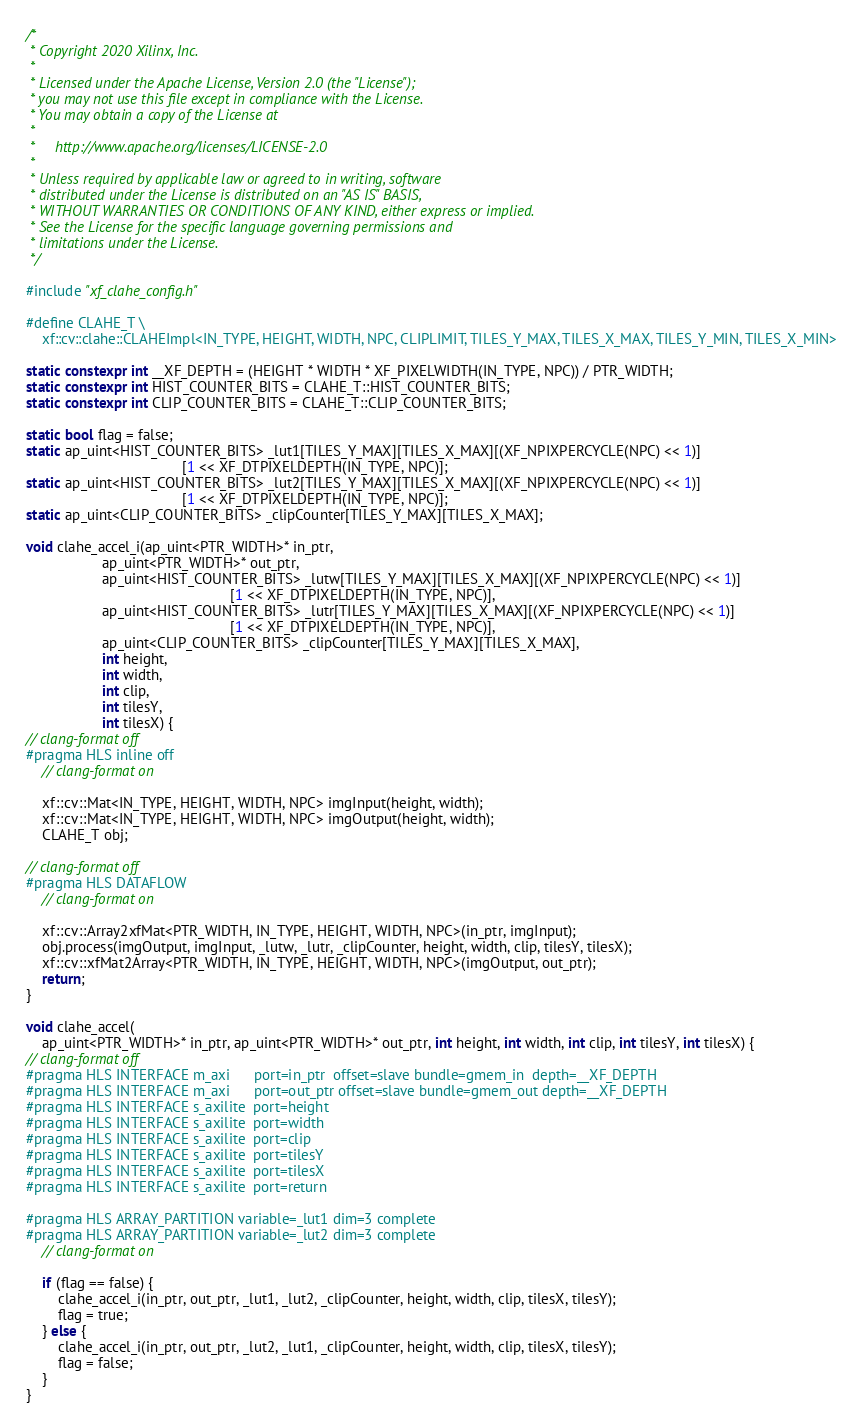<code> <loc_0><loc_0><loc_500><loc_500><_C++_>/*
 * Copyright 2020 Xilinx, Inc.
 *
 * Licensed under the Apache License, Version 2.0 (the "License");
 * you may not use this file except in compliance with the License.
 * You may obtain a copy of the License at
 *
 *     http://www.apache.org/licenses/LICENSE-2.0
 *
 * Unless required by applicable law or agreed to in writing, software
 * distributed under the License is distributed on an "AS IS" BASIS,
 * WITHOUT WARRANTIES OR CONDITIONS OF ANY KIND, either express or implied.
 * See the License for the specific language governing permissions and
 * limitations under the License.
 */

#include "xf_clahe_config.h"

#define CLAHE_T \
    xf::cv::clahe::CLAHEImpl<IN_TYPE, HEIGHT, WIDTH, NPC, CLIPLIMIT, TILES_Y_MAX, TILES_X_MAX, TILES_Y_MIN, TILES_X_MIN>

static constexpr int __XF_DEPTH = (HEIGHT * WIDTH * XF_PIXELWIDTH(IN_TYPE, NPC)) / PTR_WIDTH;
static constexpr int HIST_COUNTER_BITS = CLAHE_T::HIST_COUNTER_BITS;
static constexpr int CLIP_COUNTER_BITS = CLAHE_T::CLIP_COUNTER_BITS;

static bool flag = false;
static ap_uint<HIST_COUNTER_BITS> _lut1[TILES_Y_MAX][TILES_X_MAX][(XF_NPIXPERCYCLE(NPC) << 1)]
                                       [1 << XF_DTPIXELDEPTH(IN_TYPE, NPC)];
static ap_uint<HIST_COUNTER_BITS> _lut2[TILES_Y_MAX][TILES_X_MAX][(XF_NPIXPERCYCLE(NPC) << 1)]
                                       [1 << XF_DTPIXELDEPTH(IN_TYPE, NPC)];
static ap_uint<CLIP_COUNTER_BITS> _clipCounter[TILES_Y_MAX][TILES_X_MAX];

void clahe_accel_i(ap_uint<PTR_WIDTH>* in_ptr,
                   ap_uint<PTR_WIDTH>* out_ptr,
                   ap_uint<HIST_COUNTER_BITS> _lutw[TILES_Y_MAX][TILES_X_MAX][(XF_NPIXPERCYCLE(NPC) << 1)]
                                                   [1 << XF_DTPIXELDEPTH(IN_TYPE, NPC)],
                   ap_uint<HIST_COUNTER_BITS> _lutr[TILES_Y_MAX][TILES_X_MAX][(XF_NPIXPERCYCLE(NPC) << 1)]
                                                   [1 << XF_DTPIXELDEPTH(IN_TYPE, NPC)],
                   ap_uint<CLIP_COUNTER_BITS> _clipCounter[TILES_Y_MAX][TILES_X_MAX],
                   int height,
                   int width,
                   int clip,
                   int tilesY,
                   int tilesX) {
// clang-format off
#pragma HLS inline off
    // clang-format on

    xf::cv::Mat<IN_TYPE, HEIGHT, WIDTH, NPC> imgInput(height, width);
    xf::cv::Mat<IN_TYPE, HEIGHT, WIDTH, NPC> imgOutput(height, width);
    CLAHE_T obj;

// clang-format off
#pragma HLS DATAFLOW
    // clang-format on

    xf::cv::Array2xfMat<PTR_WIDTH, IN_TYPE, HEIGHT, WIDTH, NPC>(in_ptr, imgInput);
    obj.process(imgOutput, imgInput, _lutw, _lutr, _clipCounter, height, width, clip, tilesY, tilesX);
    xf::cv::xfMat2Array<PTR_WIDTH, IN_TYPE, HEIGHT, WIDTH, NPC>(imgOutput, out_ptr);
    return;
}

void clahe_accel(
    ap_uint<PTR_WIDTH>* in_ptr, ap_uint<PTR_WIDTH>* out_ptr, int height, int width, int clip, int tilesY, int tilesX) {
// clang-format off
#pragma HLS INTERFACE m_axi      port=in_ptr  offset=slave bundle=gmem_in  depth=__XF_DEPTH
#pragma HLS INTERFACE m_axi      port=out_ptr offset=slave bundle=gmem_out depth=__XF_DEPTH
#pragma HLS INTERFACE s_axilite  port=height
#pragma HLS INTERFACE s_axilite  port=width
#pragma HLS INTERFACE s_axilite  port=clip
#pragma HLS INTERFACE s_axilite  port=tilesY
#pragma HLS INTERFACE s_axilite  port=tilesX
#pragma HLS INTERFACE s_axilite  port=return

#pragma HLS ARRAY_PARTITION variable=_lut1 dim=3 complete
#pragma HLS ARRAY_PARTITION variable=_lut2 dim=3 complete
    // clang-format on

    if (flag == false) {
        clahe_accel_i(in_ptr, out_ptr, _lut1, _lut2, _clipCounter, height, width, clip, tilesX, tilesY);
        flag = true;
    } else {
        clahe_accel_i(in_ptr, out_ptr, _lut2, _lut1, _clipCounter, height, width, clip, tilesX, tilesY);
        flag = false;
    }
}
</code> 